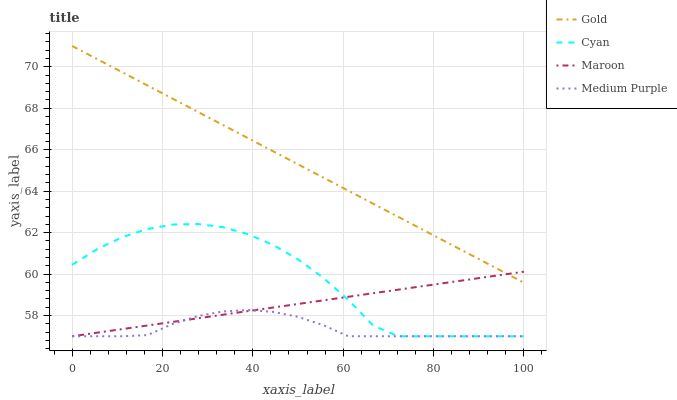Does Medium Purple have the minimum area under the curve?
Answer yes or no. Yes. Does Gold have the maximum area under the curve?
Answer yes or no. Yes. Does Cyan have the minimum area under the curve?
Answer yes or no. No. Does Cyan have the maximum area under the curve?
Answer yes or no. No. Is Maroon the smoothest?
Answer yes or no. Yes. Is Cyan the roughest?
Answer yes or no. Yes. Is Cyan the smoothest?
Answer yes or no. No. Is Maroon the roughest?
Answer yes or no. No. Does Medium Purple have the lowest value?
Answer yes or no. Yes. Does Gold have the lowest value?
Answer yes or no. No. Does Gold have the highest value?
Answer yes or no. Yes. Does Cyan have the highest value?
Answer yes or no. No. Is Medium Purple less than Gold?
Answer yes or no. Yes. Is Gold greater than Cyan?
Answer yes or no. Yes. Does Gold intersect Maroon?
Answer yes or no. Yes. Is Gold less than Maroon?
Answer yes or no. No. Is Gold greater than Maroon?
Answer yes or no. No. Does Medium Purple intersect Gold?
Answer yes or no. No. 